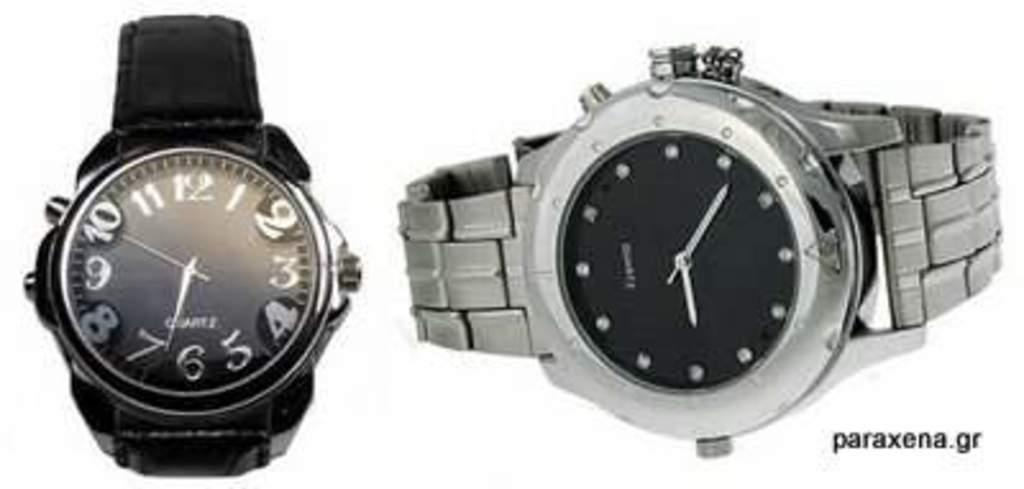<image>
Present a compact description of the photo's key features. A silver watch and a black watch, the black watch has the word Quartz at the bottom. 